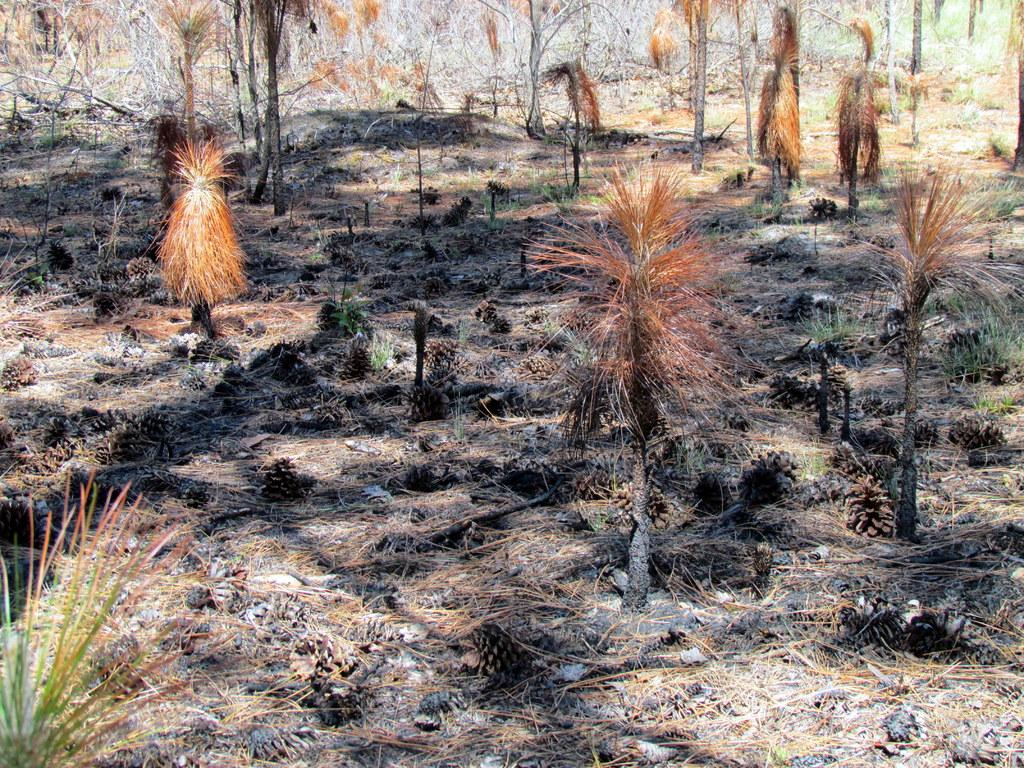What type of living organisms can be seen in the image? Plants can be seen in the image. Where are the plants located? The plants are on the land. What type of clock is present in the image? There is no clock present in the image; it only features plants on the land. Can you tell me how many judges are visible in the image? There are no judges present in the image; it only features plants on the land. 